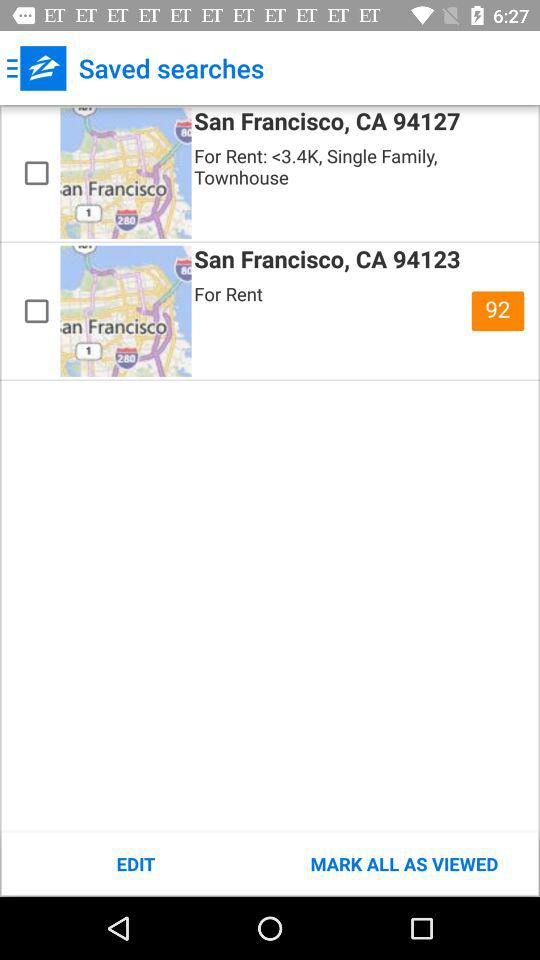How many search results are there?
Answer the question using a single word or phrase. 2 